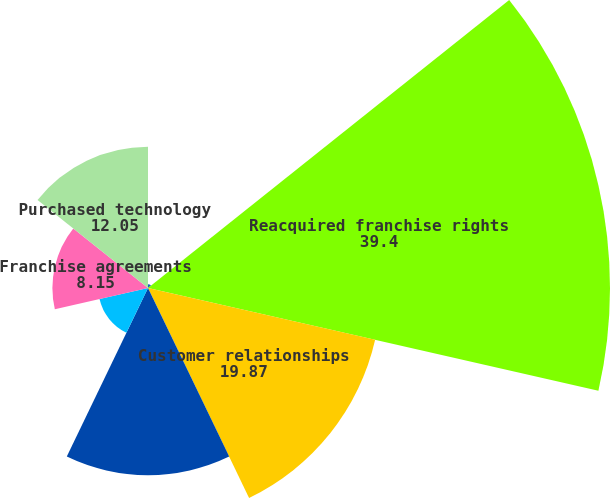<chart> <loc_0><loc_0><loc_500><loc_500><pie_chart><fcel>As of April 30<fcel>Reacquired franchise rights<fcel>Customer relationships<fcel>Internally-developed software<fcel>Noncompete agreements<fcel>Franchise agreements<fcel>Purchased technology<nl><fcel>0.33%<fcel>39.4%<fcel>19.87%<fcel>15.96%<fcel>4.24%<fcel>8.15%<fcel>12.05%<nl></chart> 